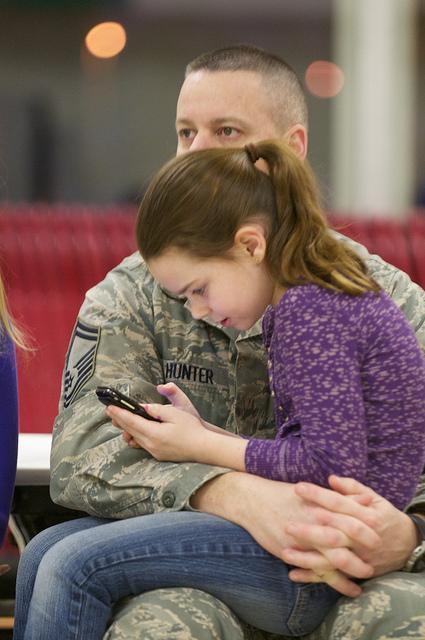How many people are visible?
Give a very brief answer. 2. How many cups are on the coffee table?
Give a very brief answer. 0. 